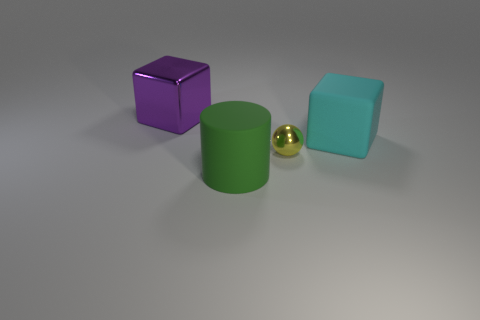What can you infer about the solidity and weight of the objects based on their appearance? The solidity and perceived weight of the objects can be inferred from their appearance and assumed materials. The cylinder and cubes look fairly solid and somewhat heavy, with the potential to be made from materials such as plastic or metal. The sphere, with its shiny metal-like appearance, looks both solid and dense, suggesting it could be heavy for its size. 